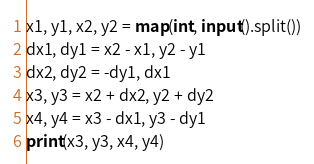<code> <loc_0><loc_0><loc_500><loc_500><_Python_>x1, y1, x2, y2 = map(int, input().split())
dx1, dy1 = x2 - x1, y2 - y1
dx2, dy2 = -dy1, dx1
x3, y3 = x2 + dx2, y2 + dy2
x4, y4 = x3 - dx1, y3 - dy1
print(x3, y3, x4, y4)</code> 